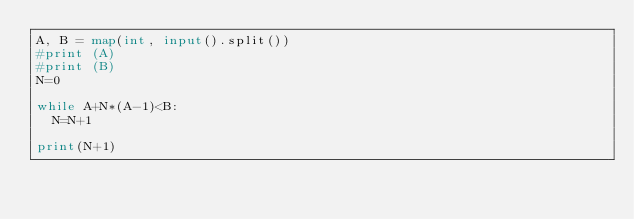Convert code to text. <code><loc_0><loc_0><loc_500><loc_500><_Python_>A, B = map(int, input().split())
#print (A)
#print (B)
N=0

while A+N*(A-1)<B:
  N=N+1

print(N+1)
</code> 